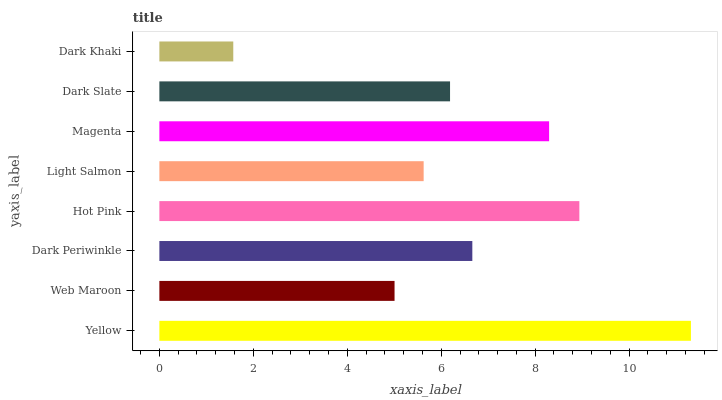Is Dark Khaki the minimum?
Answer yes or no. Yes. Is Yellow the maximum?
Answer yes or no. Yes. Is Web Maroon the minimum?
Answer yes or no. No. Is Web Maroon the maximum?
Answer yes or no. No. Is Yellow greater than Web Maroon?
Answer yes or no. Yes. Is Web Maroon less than Yellow?
Answer yes or no. Yes. Is Web Maroon greater than Yellow?
Answer yes or no. No. Is Yellow less than Web Maroon?
Answer yes or no. No. Is Dark Periwinkle the high median?
Answer yes or no. Yes. Is Dark Slate the low median?
Answer yes or no. Yes. Is Yellow the high median?
Answer yes or no. No. Is Dark Khaki the low median?
Answer yes or no. No. 